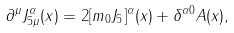Convert formula to latex. <formula><loc_0><loc_0><loc_500><loc_500>\partial ^ { \mu } J ^ { \alpha } _ { 5 \mu } ( x ) = 2 [ m _ { 0 } J _ { 5 } ] ^ { \alpha } ( x ) + \delta ^ { \alpha 0 } A ( x ) ,</formula> 